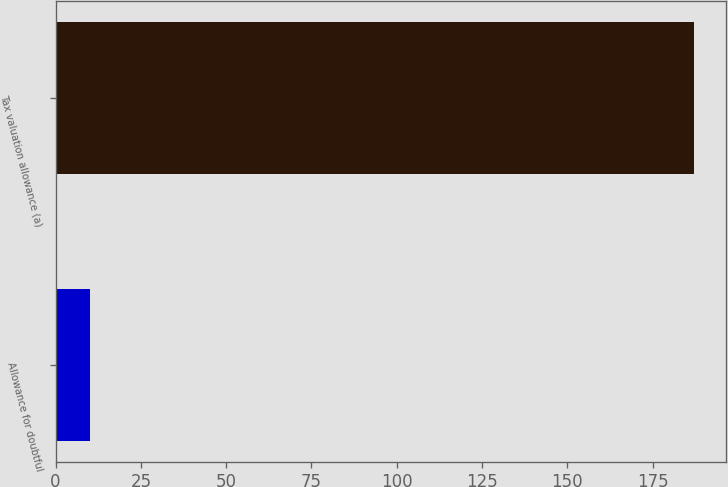<chart> <loc_0><loc_0><loc_500><loc_500><bar_chart><fcel>Allowance for doubtful<fcel>Tax valuation allowance (a)<nl><fcel>10<fcel>187<nl></chart> 